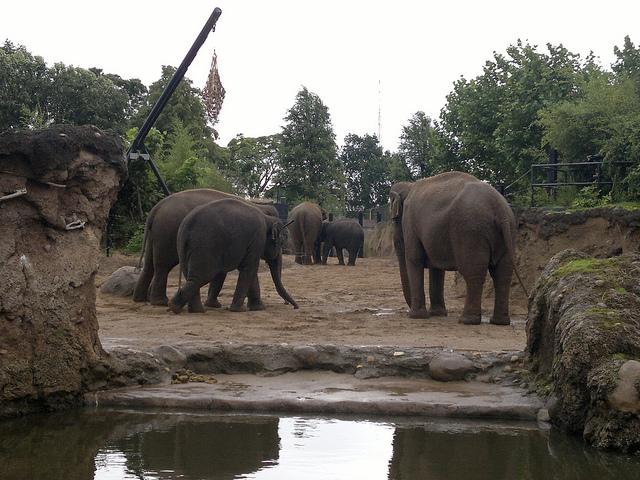Is this a game park?
Answer briefly. No. Do they have access to water?
Keep it brief. Yes. Why are there so many elephant there?
Keep it brief. Zoo. Are these elephants in the wild or in a man-made sanctuary?
Keep it brief. Man-made sanctuary. 